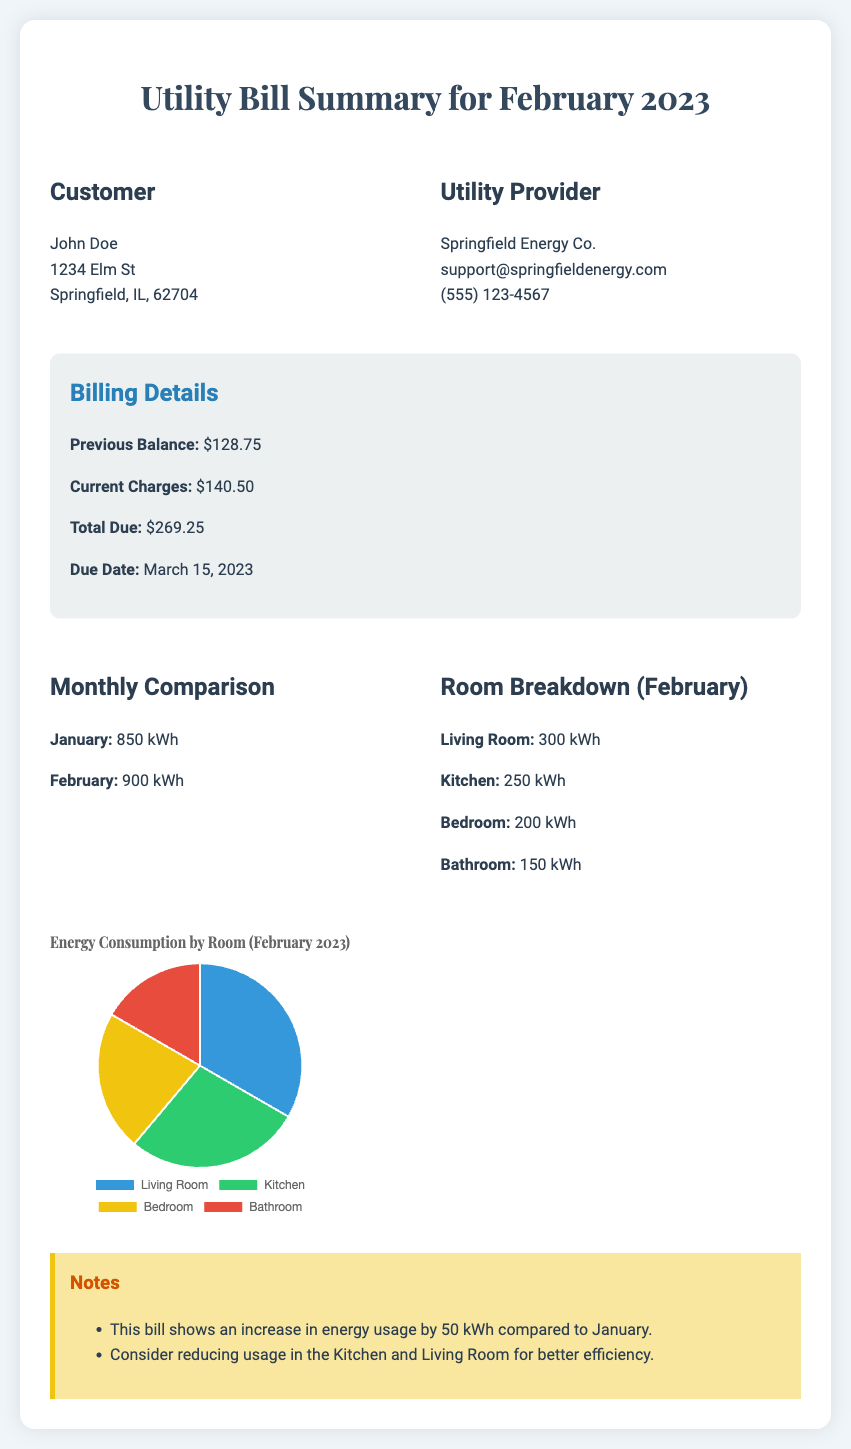What is the due date for this bill? The due date is mentioned in the billing details section of the document.
Answer: March 15, 2023 What was the previous balance? The previous balance is specified in the billing details section.
Answer: $128.75 How much was consumed in February? The total energy consumption for February is stated in the monthly comparison section.
Answer: 900 kWh Which room had the highest energy consumption? The room breakdown section lists energy consumption by each room, identifying the one with the highest usage.
Answer: Living Room What was the increase in energy usage from January to February? The notes section provides information regarding the comparison between the two months.
Answer: 50 kWh What percentage of energy did the Kitchen consume? The pie chart data indicates the distribution of energy consumption by room, particularly highlighting Kitchen's share.
Answer: 27.78 Who is the utility provider? The utility provider's details are listed in the header of the document.
Answer: Springfield Energy Co What type of chart is used in this document? The type of chart used for visualizing energy consumption is indicated in the chart configuration.
Answer: Pie chart 